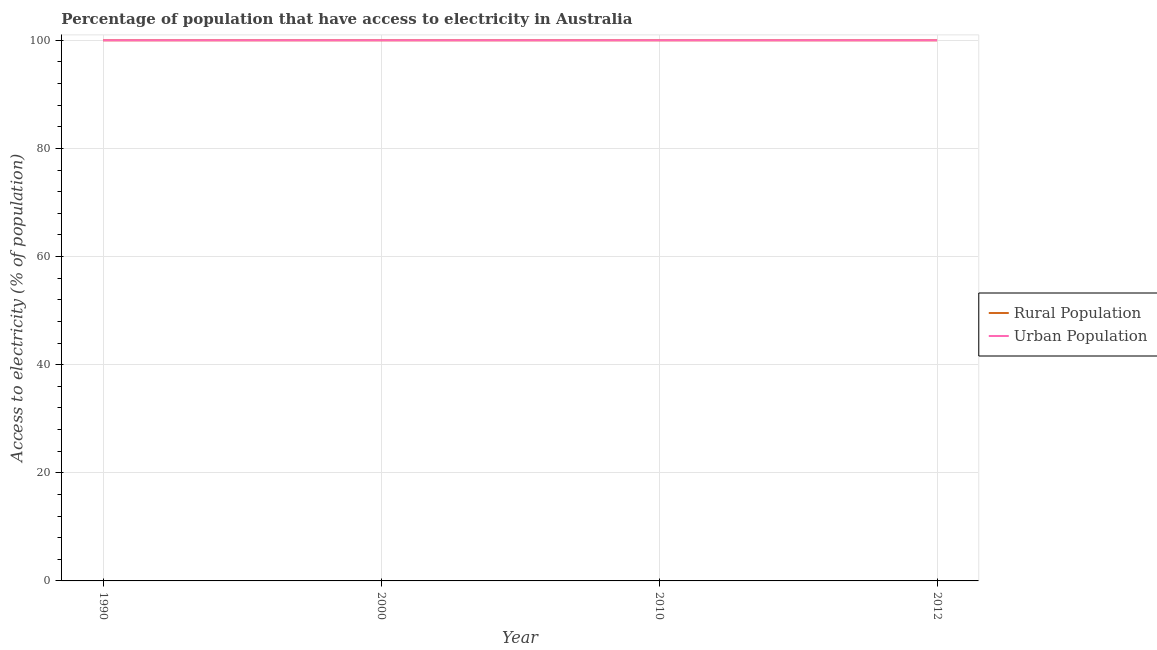Does the line corresponding to percentage of urban population having access to electricity intersect with the line corresponding to percentage of rural population having access to electricity?
Provide a succinct answer. Yes. Is the number of lines equal to the number of legend labels?
Make the answer very short. Yes. What is the percentage of urban population having access to electricity in 2000?
Keep it short and to the point. 100. Across all years, what is the maximum percentage of rural population having access to electricity?
Provide a succinct answer. 100. Across all years, what is the minimum percentage of urban population having access to electricity?
Provide a short and direct response. 100. In which year was the percentage of urban population having access to electricity maximum?
Your response must be concise. 1990. What is the total percentage of rural population having access to electricity in the graph?
Your answer should be very brief. 400. What is the difference between the percentage of rural population having access to electricity in 1990 and that in 2012?
Give a very brief answer. 0. What is the average percentage of rural population having access to electricity per year?
Offer a very short reply. 100. In the year 1990, what is the difference between the percentage of urban population having access to electricity and percentage of rural population having access to electricity?
Keep it short and to the point. 0. What is the ratio of the percentage of urban population having access to electricity in 1990 to that in 2012?
Your answer should be compact. 1. Is the difference between the percentage of urban population having access to electricity in 1990 and 2010 greater than the difference between the percentage of rural population having access to electricity in 1990 and 2010?
Keep it short and to the point. No. Is the percentage of urban population having access to electricity strictly greater than the percentage of rural population having access to electricity over the years?
Provide a succinct answer. No. How many years are there in the graph?
Provide a short and direct response. 4. What is the difference between two consecutive major ticks on the Y-axis?
Offer a terse response. 20. Where does the legend appear in the graph?
Give a very brief answer. Center right. How many legend labels are there?
Provide a short and direct response. 2. What is the title of the graph?
Offer a very short reply. Percentage of population that have access to electricity in Australia. What is the label or title of the Y-axis?
Provide a succinct answer. Access to electricity (% of population). What is the Access to electricity (% of population) of Rural Population in 1990?
Provide a short and direct response. 100. What is the Access to electricity (% of population) in Urban Population in 1990?
Your answer should be compact. 100. What is the Access to electricity (% of population) of Rural Population in 2012?
Keep it short and to the point. 100. What is the Access to electricity (% of population) of Urban Population in 2012?
Offer a very short reply. 100. Across all years, what is the maximum Access to electricity (% of population) in Rural Population?
Give a very brief answer. 100. Across all years, what is the maximum Access to electricity (% of population) in Urban Population?
Your answer should be compact. 100. Across all years, what is the minimum Access to electricity (% of population) in Rural Population?
Your response must be concise. 100. What is the total Access to electricity (% of population) in Urban Population in the graph?
Make the answer very short. 400. What is the difference between the Access to electricity (% of population) in Rural Population in 1990 and that in 2000?
Make the answer very short. 0. What is the difference between the Access to electricity (% of population) in Urban Population in 1990 and that in 2000?
Provide a short and direct response. 0. What is the difference between the Access to electricity (% of population) in Rural Population in 1990 and that in 2010?
Your answer should be very brief. 0. What is the difference between the Access to electricity (% of population) of Urban Population in 1990 and that in 2010?
Offer a very short reply. 0. What is the difference between the Access to electricity (% of population) in Rural Population in 1990 and that in 2012?
Your answer should be very brief. 0. What is the difference between the Access to electricity (% of population) of Rural Population in 2000 and that in 2010?
Your answer should be very brief. 0. What is the difference between the Access to electricity (% of population) in Rural Population in 2010 and that in 2012?
Offer a very short reply. 0. What is the difference between the Access to electricity (% of population) in Urban Population in 2010 and that in 2012?
Ensure brevity in your answer.  0. What is the difference between the Access to electricity (% of population) in Rural Population in 1990 and the Access to electricity (% of population) in Urban Population in 2000?
Provide a short and direct response. 0. What is the difference between the Access to electricity (% of population) in Rural Population in 2000 and the Access to electricity (% of population) in Urban Population in 2010?
Offer a very short reply. 0. What is the difference between the Access to electricity (% of population) in Rural Population in 2000 and the Access to electricity (% of population) in Urban Population in 2012?
Keep it short and to the point. 0. What is the difference between the Access to electricity (% of population) of Rural Population in 2010 and the Access to electricity (% of population) of Urban Population in 2012?
Keep it short and to the point. 0. In the year 2012, what is the difference between the Access to electricity (% of population) of Rural Population and Access to electricity (% of population) of Urban Population?
Your answer should be compact. 0. What is the ratio of the Access to electricity (% of population) in Rural Population in 1990 to that in 2010?
Make the answer very short. 1. What is the ratio of the Access to electricity (% of population) of Urban Population in 1990 to that in 2010?
Ensure brevity in your answer.  1. What is the ratio of the Access to electricity (% of population) in Rural Population in 2000 to that in 2010?
Provide a succinct answer. 1. What is the ratio of the Access to electricity (% of population) of Urban Population in 2000 to that in 2010?
Give a very brief answer. 1. What is the ratio of the Access to electricity (% of population) of Urban Population in 2000 to that in 2012?
Provide a succinct answer. 1. What is the ratio of the Access to electricity (% of population) of Urban Population in 2010 to that in 2012?
Your answer should be very brief. 1. What is the difference between the highest and the lowest Access to electricity (% of population) of Urban Population?
Your answer should be very brief. 0. 